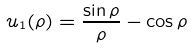Convert formula to latex. <formula><loc_0><loc_0><loc_500><loc_500>u _ { 1 } ( \rho ) = \frac { \sin { \rho } } { \rho } - \cos { \rho }</formula> 